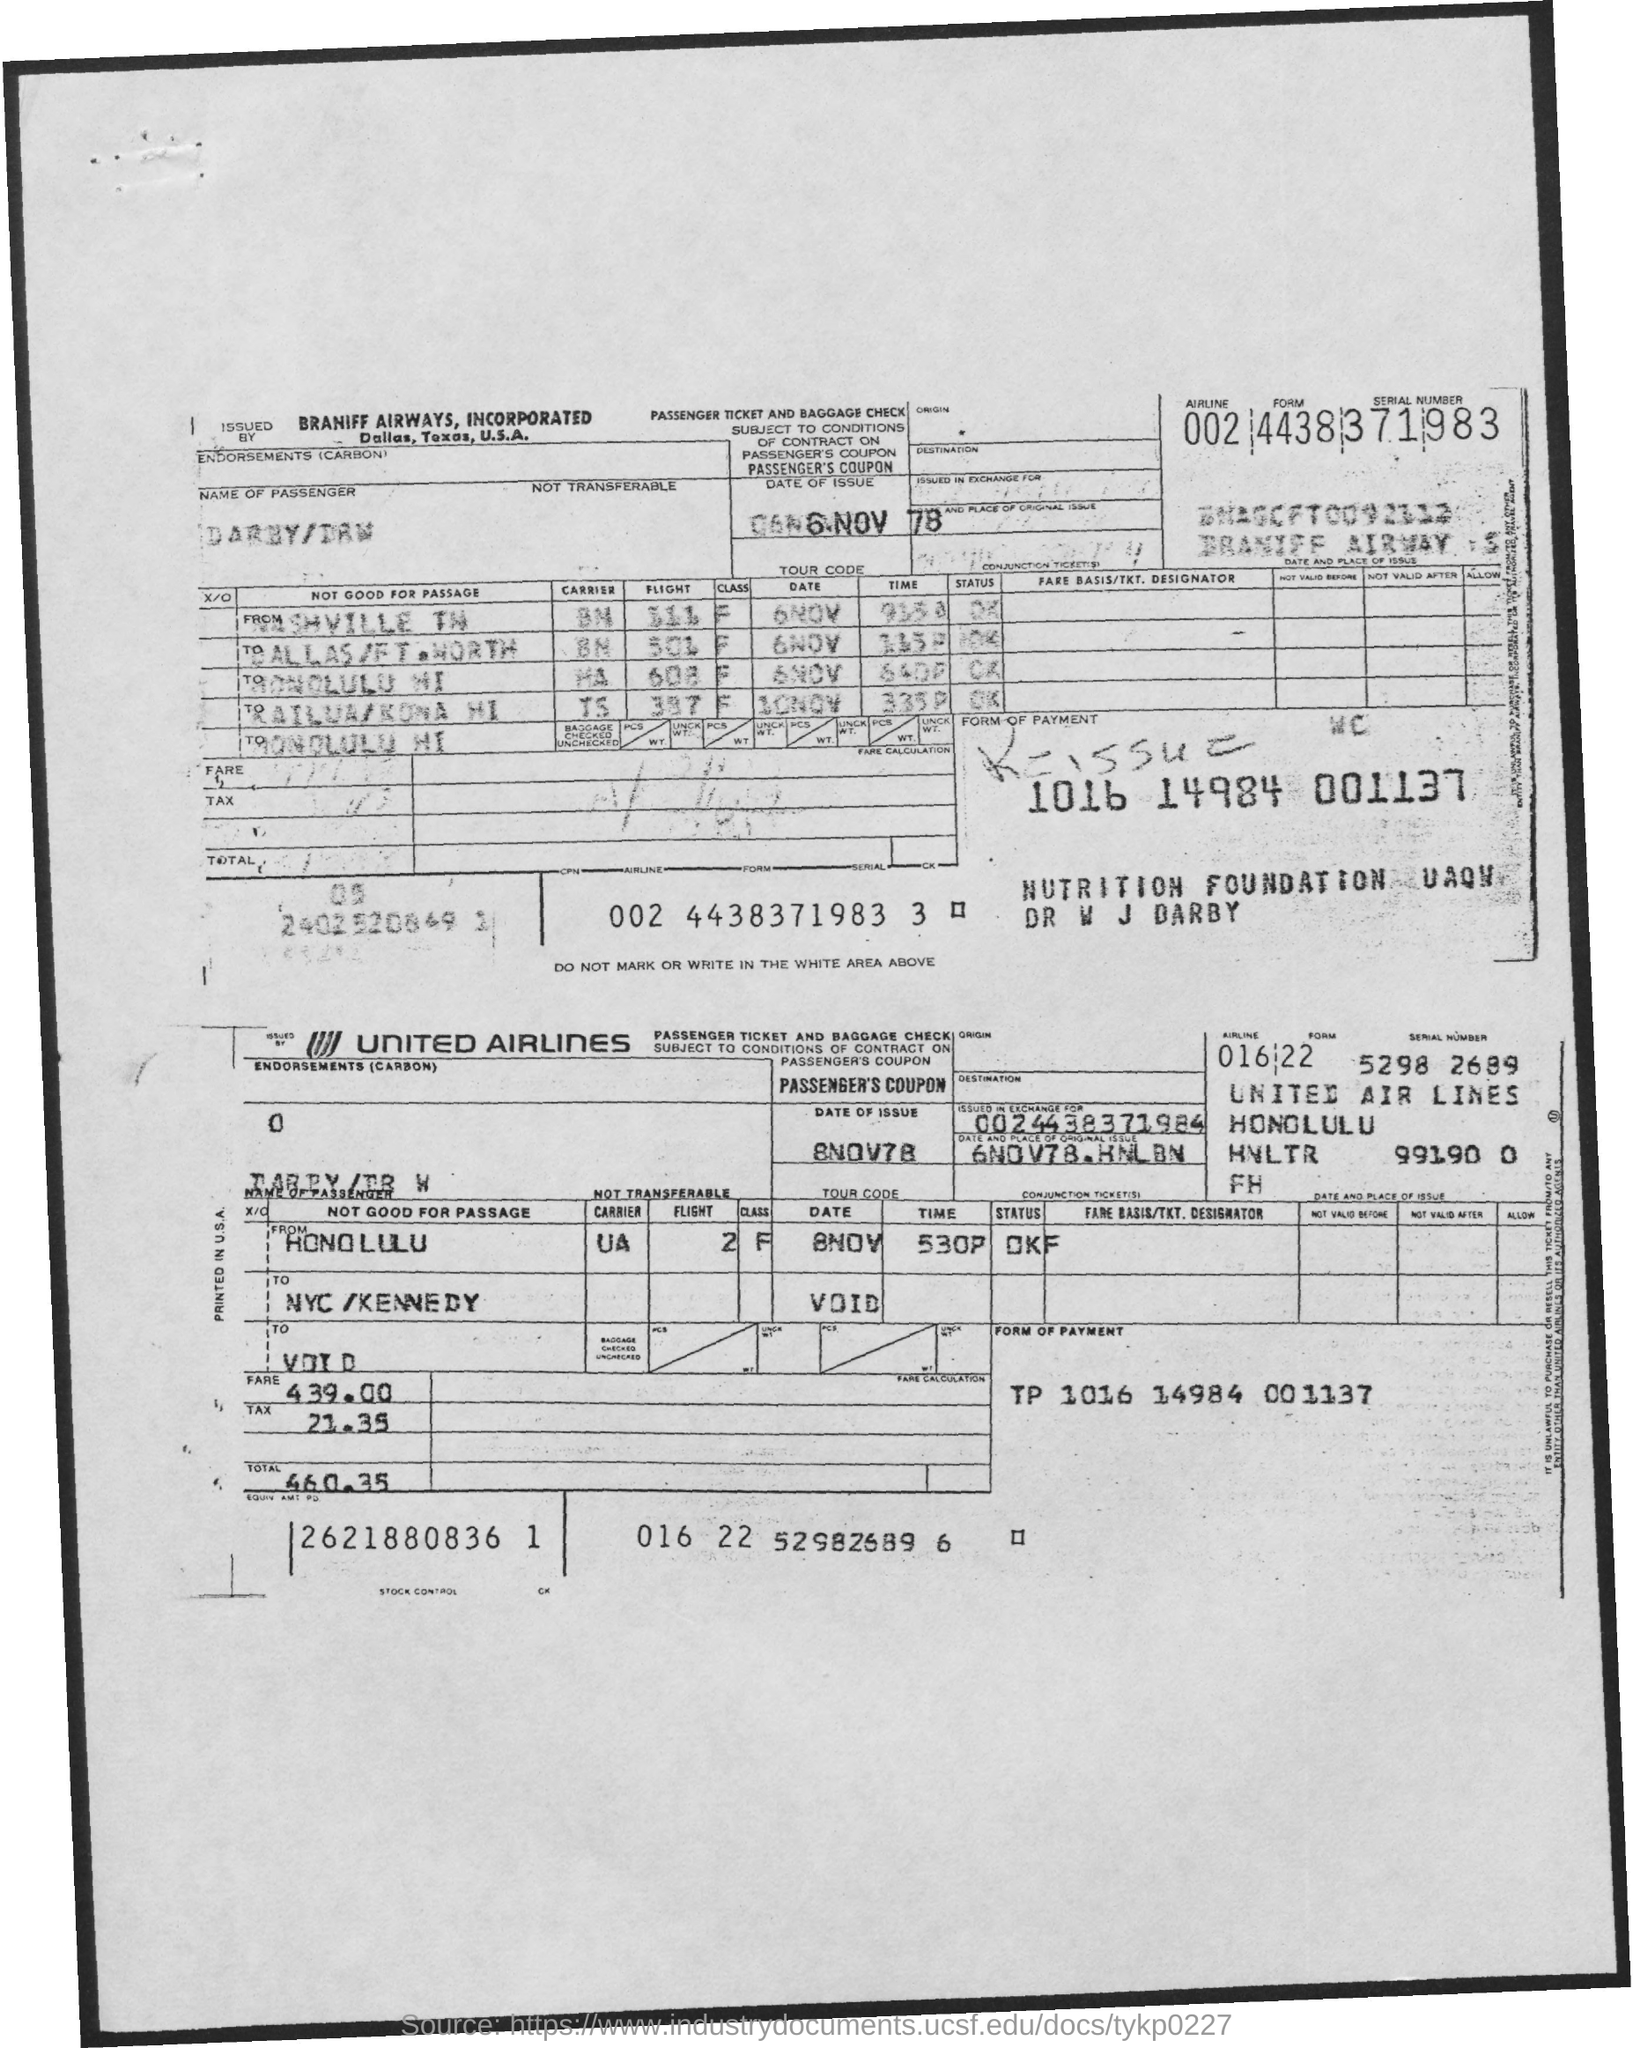Point out several critical features in this image. The tax is 21.35. The original issue date of this document is November 6, 1978, in Honolulu, Hawaii. The total is 460.35, rounded down to the nearest cent. The American Express Card is issued in exchange for a fee. United Airlines is the carrier departing from Honolulu. 